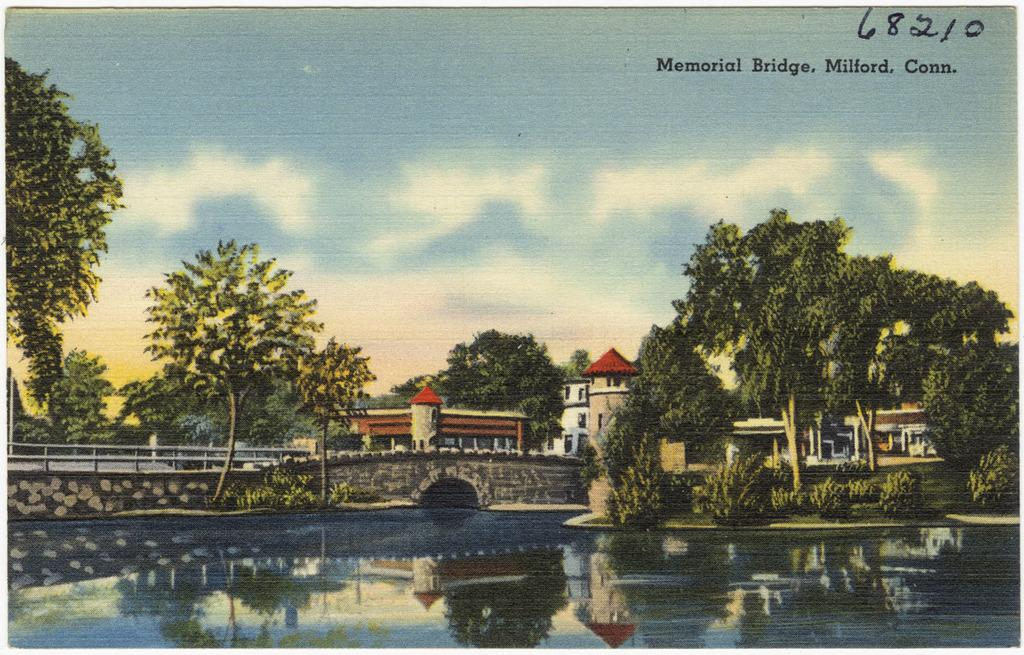What is the primary element in the image? There is water in the image. What structure can be seen crossing over the water? There is a bridge in the image. What type of vegetation is present in the image? There are trees in the image. What type of man-made structures can be seen in the image? There are buildings in the image. What is visible in the sky in the image? There are clouds in the image. What part of the natural environment is visible in the image? The sky is visible in the image. What is the nature of the image? The image is a painting. Are there any words or letters present in the image? There is text written in the image. How does the spring affect the water in the image? There is no mention of a spring in the image, and therefore its effect on the water cannot be determined. 